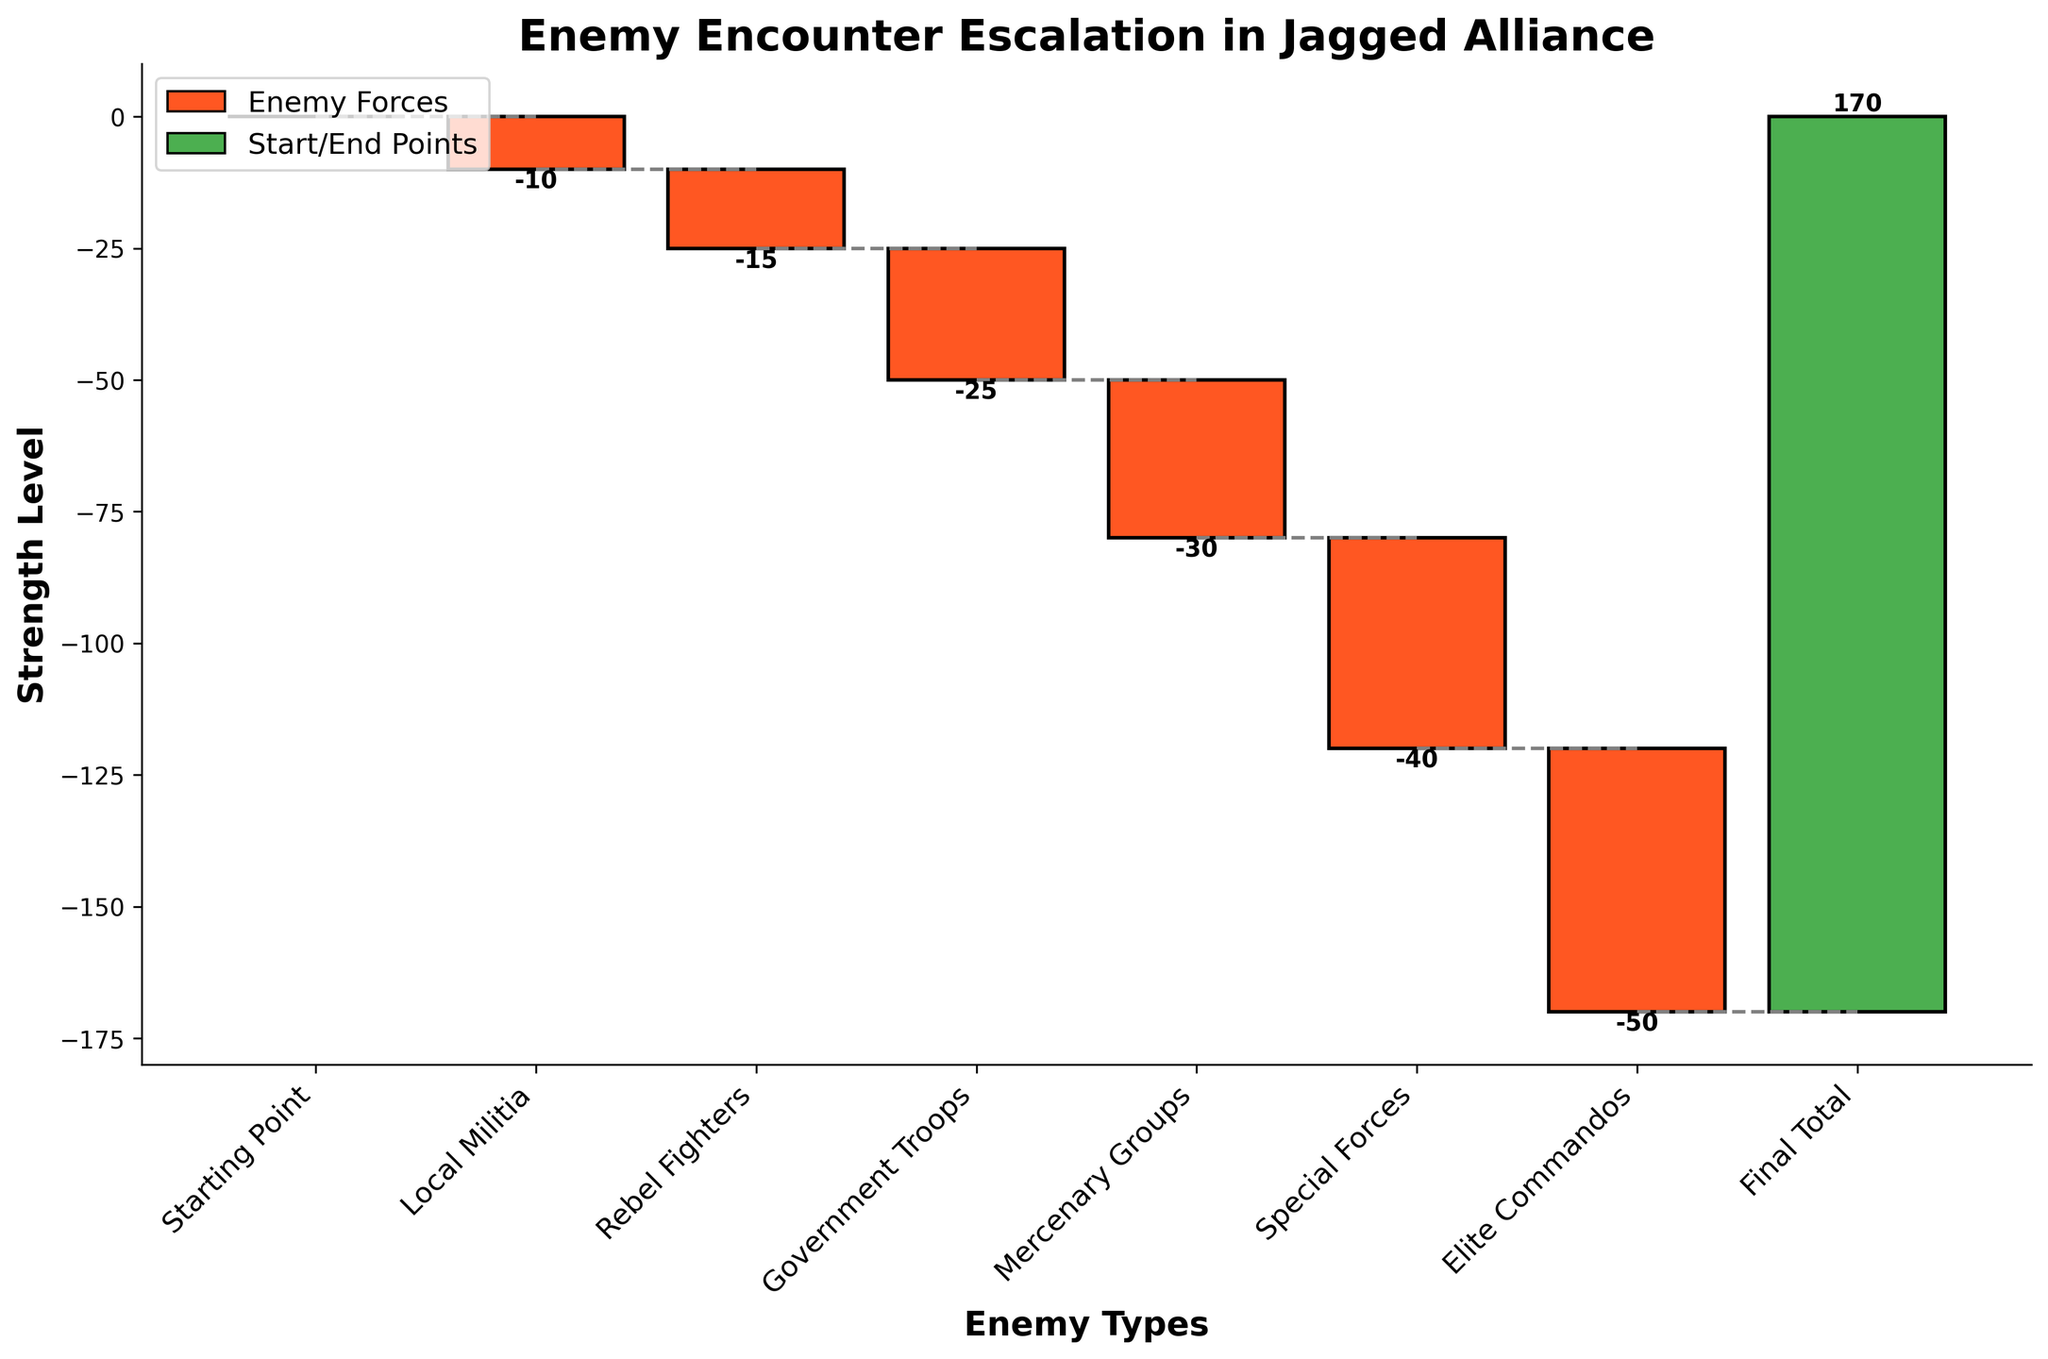What's the title of the figure? The title of the figure is usually at the top center and clearly indicates the main subject. Here, it is "Enemy Encounter Escalation in Jagged Alliance."
Answer: Enemy Encounter Escalation in Jagged Alliance What is shown on the y-axis? The y-axis typically represents the variable being measured. Here, it indicates "Strength Level."
Answer: Strength Level How many enemy types are represented in the figure? By counting the categories on the x-axis, we see: Local Militia, Rebel Fighters, Government Troops, Mercenary Groups, Special Forces, Elite Commandos, and Final Total.
Answer: 6 What colors are used in the chart, and what do they represent? Green is used for the starting and ending points, red is used for negative values, and blue (though not present in this dataset) would be for positive changes.
Answer: Green and Red What's the range of the y-axis shown in the figure? The y-axis limits define the space within which the data is plotted. Here, the minimum cumulative value goes down to -125, and the highest cumulative value reaches up to 170, with some buffer.
Answer: Approximately -125 to 180 How does the strength level change from Local Militia to Special Forces? The strength level progressively decreases. Starting from -10 (Local Militia), to -15 (Rebel Fighters), to -25 (Government Troops), to -30 (Mercenary Groups), and finally to -40 (Special Forces).
Answer: Progressively Decreases What is the cumulative strength level after encountering Elite Commandos? The cumulative strength level is the sum of values up to that point. Starting at 0 and adding the negative values: 0 + (-10) + (-15) + (-25) + (-30) + (-40) + (-50) = -170.
Answer: -170 Which enemy type causes the largest decrease in strength level? Comparing the negative values: Local Militia (-10), Rebel Fighters (-15), Government Troops (-25), Mercenary Groups (-30), Special Forces (-40), Elite Commandos (-50). Elite Commandos cause the largest decrease.
Answer: Elite Commandos What is the Final Total strength level, and how does it compare to the starting point? The Final Total is 170, compared to the starting point which is 0. The difference is 170 - 0 = 170.
Answer: 170 